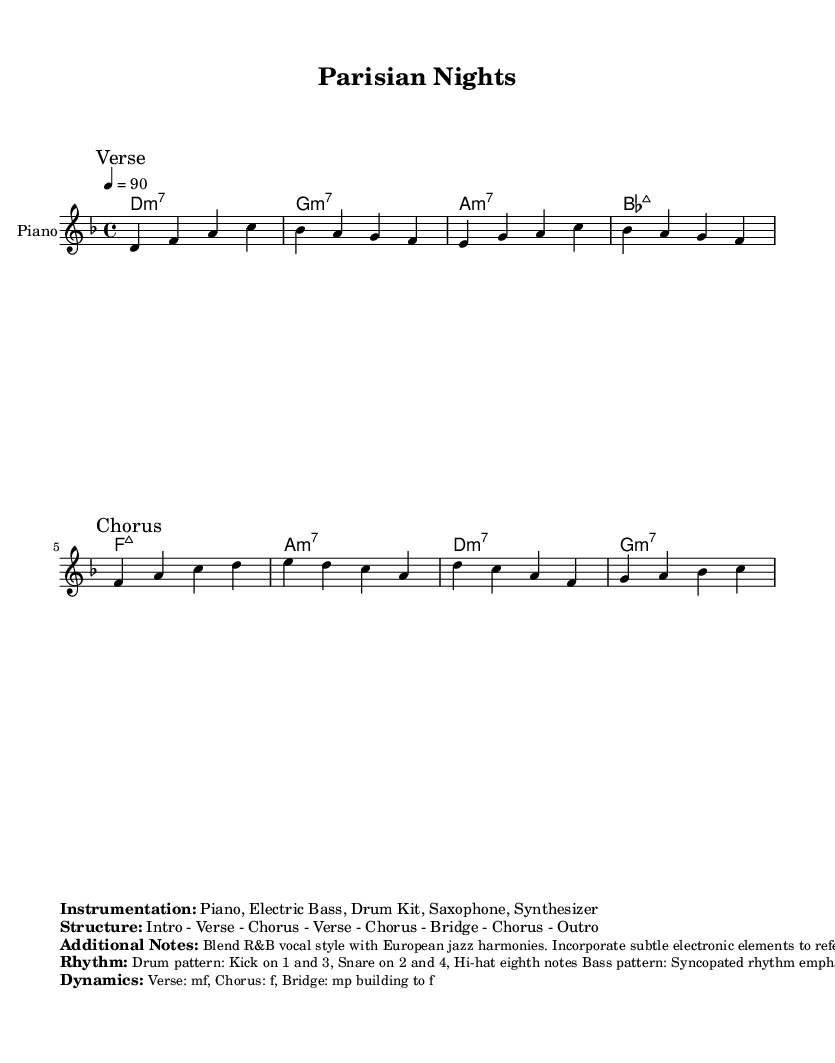What is the key signature of this music? The key signature is indicated in the global section under \key, which shows d minor as the key.
Answer: d minor What is the time signature of the piece? The time signature is found in the global section under \time, which indicates that the piece is in 4/4 time.
Answer: 4/4 What is the tempo marking? The tempo marking is present in the global section, which indicates the tempo is 90 beats per minute.
Answer: 90 What is the main instrument featured in this piece? The instrument name is defined in the score as "Piano," meaning it primarily features the piano.
Answer: Piano Describe the structure of the song. The structure is marked in the score, detailing the sequence of sections: Intro, Verse, Chorus, Verse, Chorus, Bridge, Chorus, Outro.
Answer: Intro - Verse - Chorus - Verse - Chorus - Bridge - Chorus - Outro How does the rhythm section contribute to the feel of the piece? The description of the rhythm in the markup notes indicates a kick on beats 1 and 3, with a snare on beats 2 and 4, and hi-hat eighth notes, creating a syncopated feel typical of R&B.
Answer: Syncopated rhythm What dynamic levels are indicated for the Chorus? The description of dynamics notes that the Chorus is marked with a dynamic level of f, which means "forte" or loud, creating an energetic sound at that point in the piece.
Answer: f 